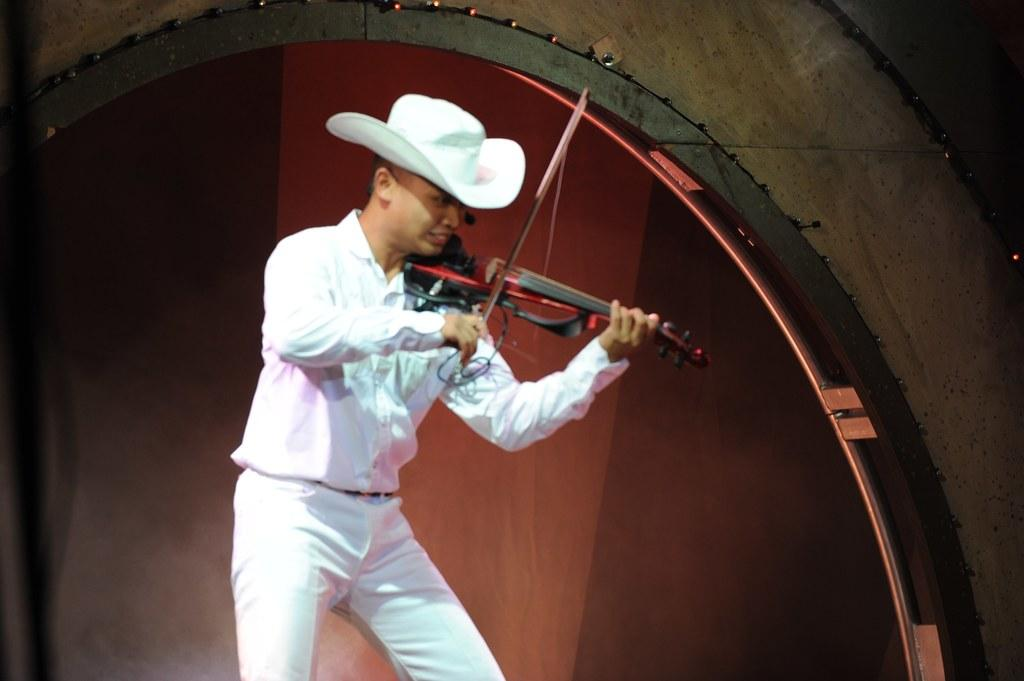What is the man in the image holding? The man is holding a violin. What is the man doing with the violin? The man is playing the violin. Can you describe the man's hat? The man is wearing a white color hat. What can be seen in the background of the image? There is a red color wall in the background, and lights are visible on the wall. What type of pipe is visible in the image? There is no pipe present in the image. How does the man play the violin in a different way in the image? The image only shows the man playing the violin in one way, so it cannot be determined if he plays it differently. 